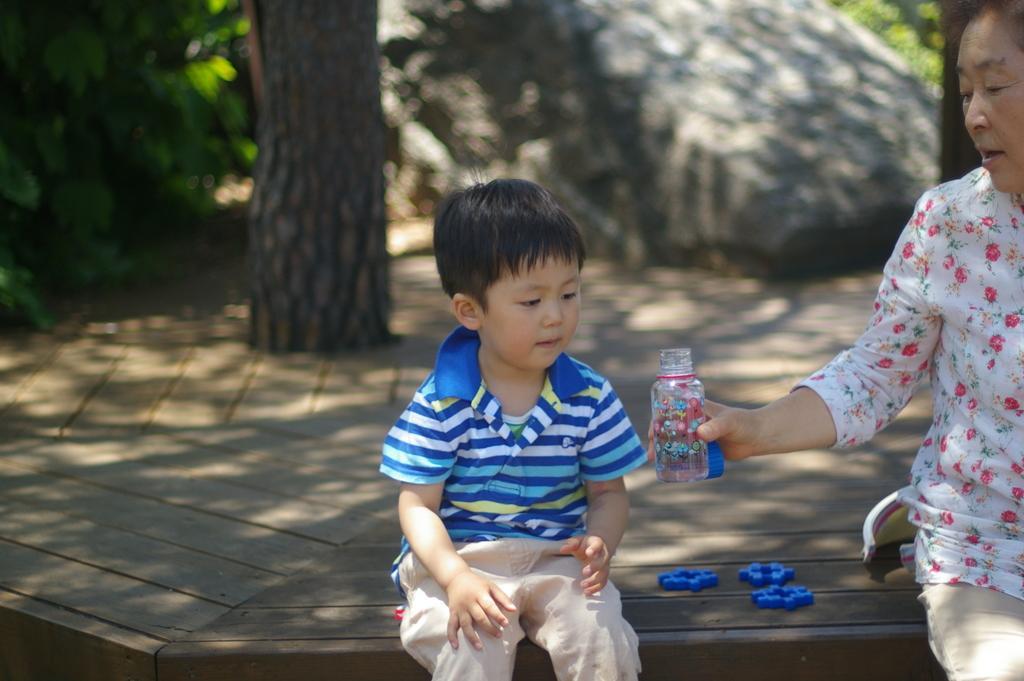Can you describe this image briefly? In the picture we can see a boy sitting near the tree beside the boy and we can see a person sitting and giving a bottle to the boy and in the background we can see a rock and some plants. 